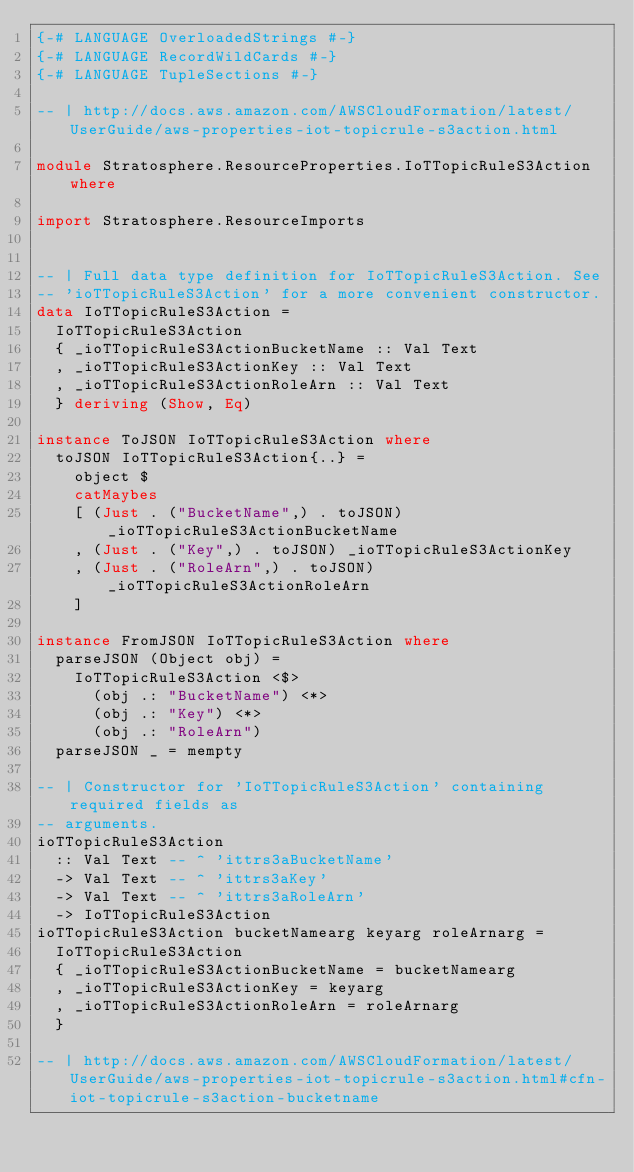<code> <loc_0><loc_0><loc_500><loc_500><_Haskell_>{-# LANGUAGE OverloadedStrings #-}
{-# LANGUAGE RecordWildCards #-}
{-# LANGUAGE TupleSections #-}

-- | http://docs.aws.amazon.com/AWSCloudFormation/latest/UserGuide/aws-properties-iot-topicrule-s3action.html

module Stratosphere.ResourceProperties.IoTTopicRuleS3Action where

import Stratosphere.ResourceImports


-- | Full data type definition for IoTTopicRuleS3Action. See
-- 'ioTTopicRuleS3Action' for a more convenient constructor.
data IoTTopicRuleS3Action =
  IoTTopicRuleS3Action
  { _ioTTopicRuleS3ActionBucketName :: Val Text
  , _ioTTopicRuleS3ActionKey :: Val Text
  , _ioTTopicRuleS3ActionRoleArn :: Val Text
  } deriving (Show, Eq)

instance ToJSON IoTTopicRuleS3Action where
  toJSON IoTTopicRuleS3Action{..} =
    object $
    catMaybes
    [ (Just . ("BucketName",) . toJSON) _ioTTopicRuleS3ActionBucketName
    , (Just . ("Key",) . toJSON) _ioTTopicRuleS3ActionKey
    , (Just . ("RoleArn",) . toJSON) _ioTTopicRuleS3ActionRoleArn
    ]

instance FromJSON IoTTopicRuleS3Action where
  parseJSON (Object obj) =
    IoTTopicRuleS3Action <$>
      (obj .: "BucketName") <*>
      (obj .: "Key") <*>
      (obj .: "RoleArn")
  parseJSON _ = mempty

-- | Constructor for 'IoTTopicRuleS3Action' containing required fields as
-- arguments.
ioTTopicRuleS3Action
  :: Val Text -- ^ 'ittrs3aBucketName'
  -> Val Text -- ^ 'ittrs3aKey'
  -> Val Text -- ^ 'ittrs3aRoleArn'
  -> IoTTopicRuleS3Action
ioTTopicRuleS3Action bucketNamearg keyarg roleArnarg =
  IoTTopicRuleS3Action
  { _ioTTopicRuleS3ActionBucketName = bucketNamearg
  , _ioTTopicRuleS3ActionKey = keyarg
  , _ioTTopicRuleS3ActionRoleArn = roleArnarg
  }

-- | http://docs.aws.amazon.com/AWSCloudFormation/latest/UserGuide/aws-properties-iot-topicrule-s3action.html#cfn-iot-topicrule-s3action-bucketname</code> 